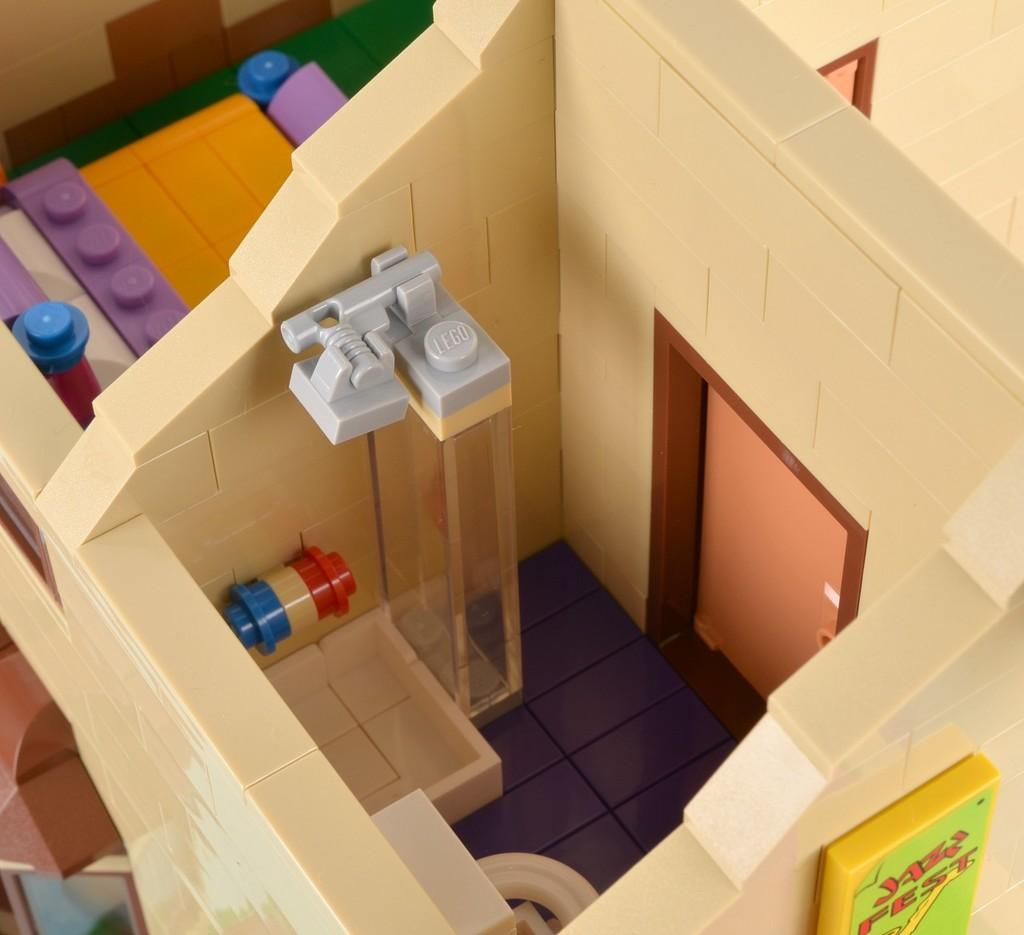What is the main subject of the image? The main subject of the image is a toy house. Where is the toy house located in the image? The toy house is in the center of the image. Can you see any bees buzzing around the toy house in the image? There are no bees visible in the image; it only features a toy house. What type of attention is the toy house receiving in the image? The image does not depict the toy house receiving any specific type of attention. 